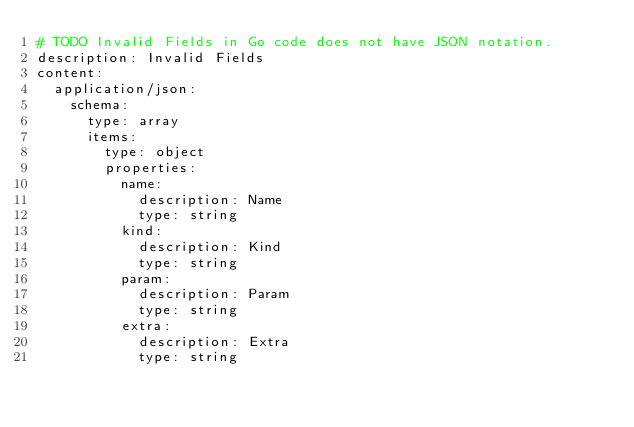<code> <loc_0><loc_0><loc_500><loc_500><_YAML_># TODO Invalid Fields in Go code does not have JSON notation.
description: Invalid Fields
content:
  application/json:
    schema:
      type: array
      items:
        type: object
        properties:
          name:
            description: Name
            type: string
          kind:
            description: Kind
            type: string
          param:
            description: Param
            type: string
          extra:
            description: Extra
            type: string
</code> 